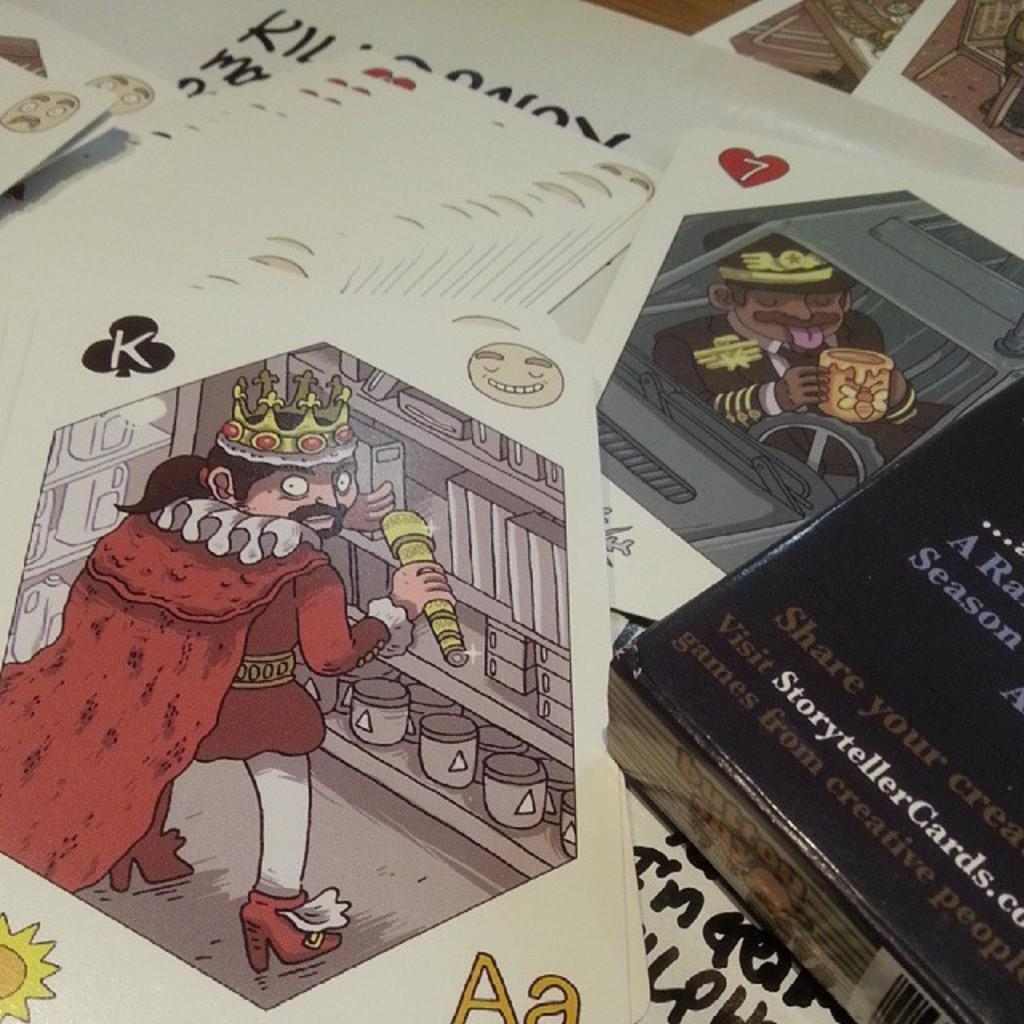<image>
Provide a brief description of the given image. A black product package displays the website name Storytellercards.com. 